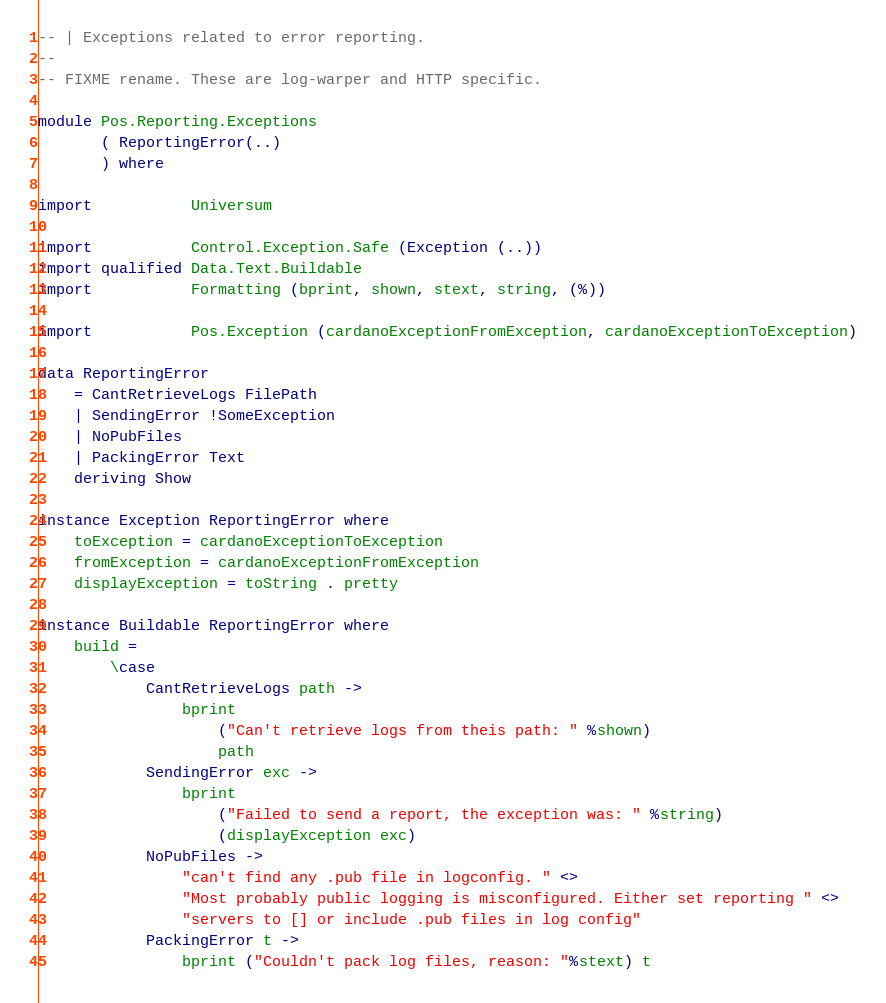<code> <loc_0><loc_0><loc_500><loc_500><_Haskell_>-- | Exceptions related to error reporting.
--
-- FIXME rename. These are log-warper and HTTP specific.

module Pos.Reporting.Exceptions
       ( ReportingError(..)
       ) where

import           Universum

import           Control.Exception.Safe (Exception (..))
import qualified Data.Text.Buildable
import           Formatting (bprint, shown, stext, string, (%))

import           Pos.Exception (cardanoExceptionFromException, cardanoExceptionToException)

data ReportingError
    = CantRetrieveLogs FilePath
    | SendingError !SomeException
    | NoPubFiles
    | PackingError Text
    deriving Show

instance Exception ReportingError where
    toException = cardanoExceptionToException
    fromException = cardanoExceptionFromException
    displayException = toString . pretty

instance Buildable ReportingError where
    build =
        \case
            CantRetrieveLogs path ->
                bprint
                    ("Can't retrieve logs from theis path: " %shown)
                    path
            SendingError exc ->
                bprint
                    ("Failed to send a report, the exception was: " %string)
                    (displayException exc)
            NoPubFiles ->
                "can't find any .pub file in logconfig. " <>
                "Most probably public logging is misconfigured. Either set reporting " <>
                "servers to [] or include .pub files in log config"
            PackingError t ->
                bprint ("Couldn't pack log files, reason: "%stext) t
</code> 